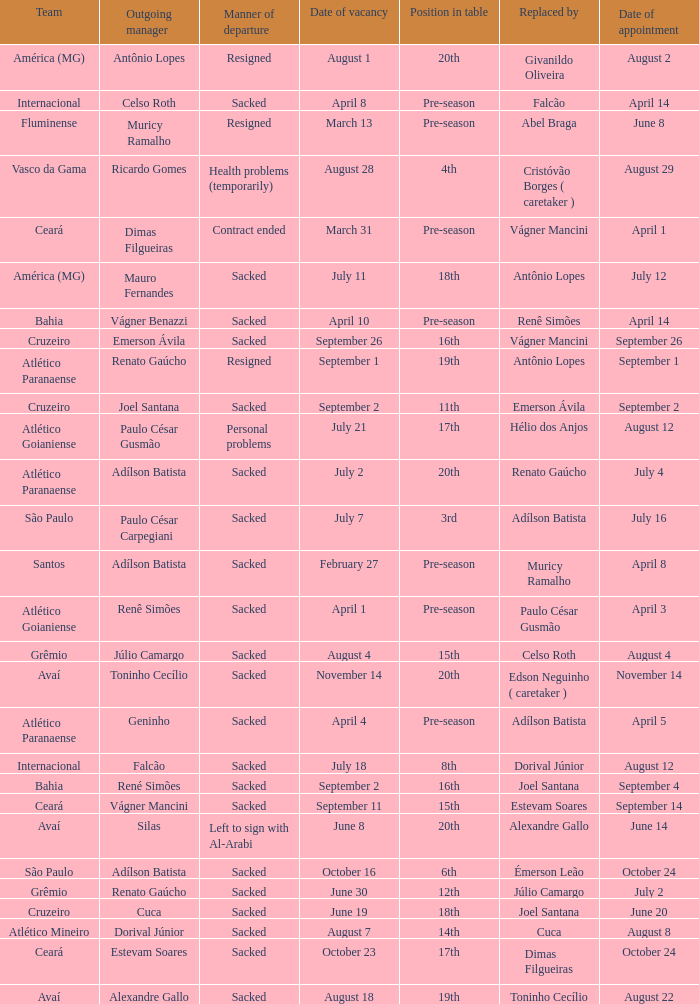Who was the new Santos manager? Muricy Ramalho. 